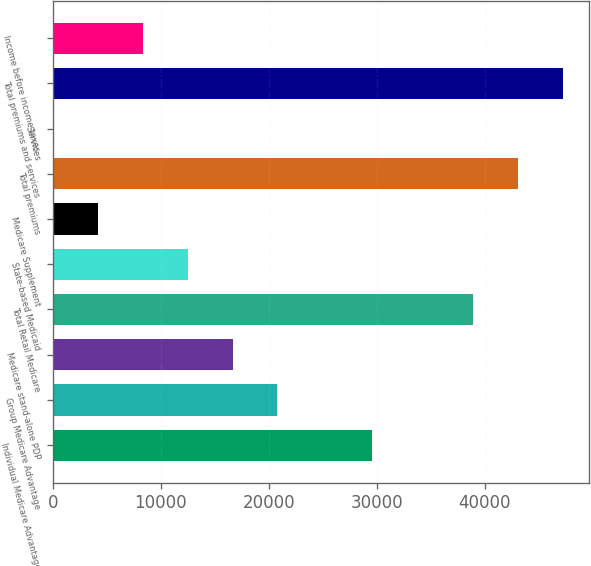Convert chart. <chart><loc_0><loc_0><loc_500><loc_500><bar_chart><fcel>Individual Medicare Advantage<fcel>Group Medicare Advantage<fcel>Medicare stand-alone PDP<fcel>Total Retail Medicare<fcel>State-based Medicaid<fcel>Medicare Supplement<fcel>Total premiums<fcel>Services<fcel>Total premiums and services<fcel>Income before income taxes<nl><fcel>29526<fcel>20810.5<fcel>16650<fcel>38960<fcel>12489.5<fcel>4168.5<fcel>43120.5<fcel>8<fcel>47281<fcel>8329<nl></chart> 